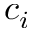Convert formula to latex. <formula><loc_0><loc_0><loc_500><loc_500>c _ { i }</formula> 